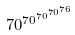Convert formula to latex. <formula><loc_0><loc_0><loc_500><loc_500>7 0 ^ { 7 0 ^ { 7 0 ^ { 7 0 ^ { 7 6 } } } }</formula> 